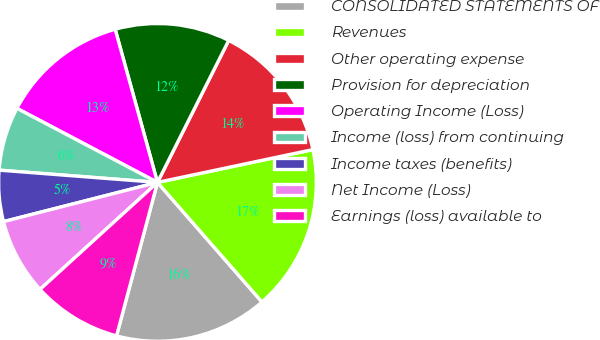Convert chart to OTSL. <chart><loc_0><loc_0><loc_500><loc_500><pie_chart><fcel>CONSOLIDATED STATEMENTS OF<fcel>Revenues<fcel>Other operating expense<fcel>Provision for depreciation<fcel>Operating Income (Loss)<fcel>Income (loss) from continuing<fcel>Income taxes (benefits)<fcel>Net Income (Loss)<fcel>Earnings (loss) available to<nl><fcel>15.58%<fcel>16.88%<fcel>14.29%<fcel>11.69%<fcel>12.99%<fcel>6.49%<fcel>5.2%<fcel>7.79%<fcel>9.09%<nl></chart> 